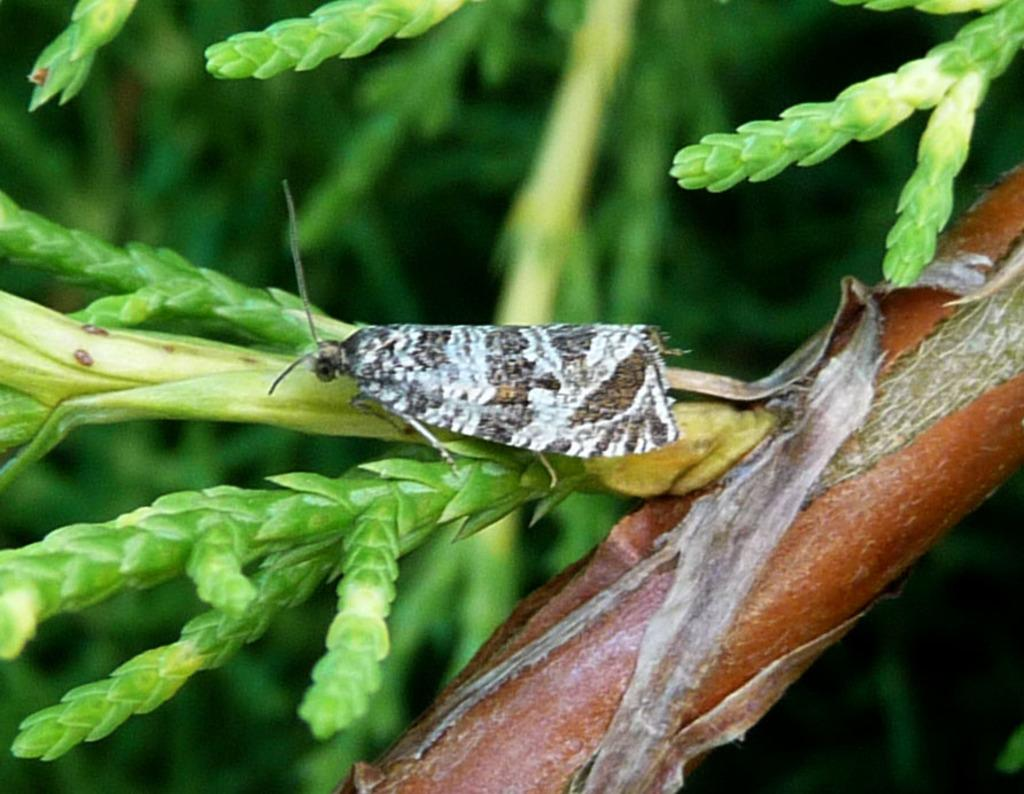What type of plant life is visible in the image? There are stems with leaves in the image. Are there any animals or insects present in the image? Yes, there is an insect on a stem in the image. In which direction is the insect facing? The insect is facing towards the left side. What type of print can be seen on the insect's face in the image? There is no print or face visible on the insect in the image. 